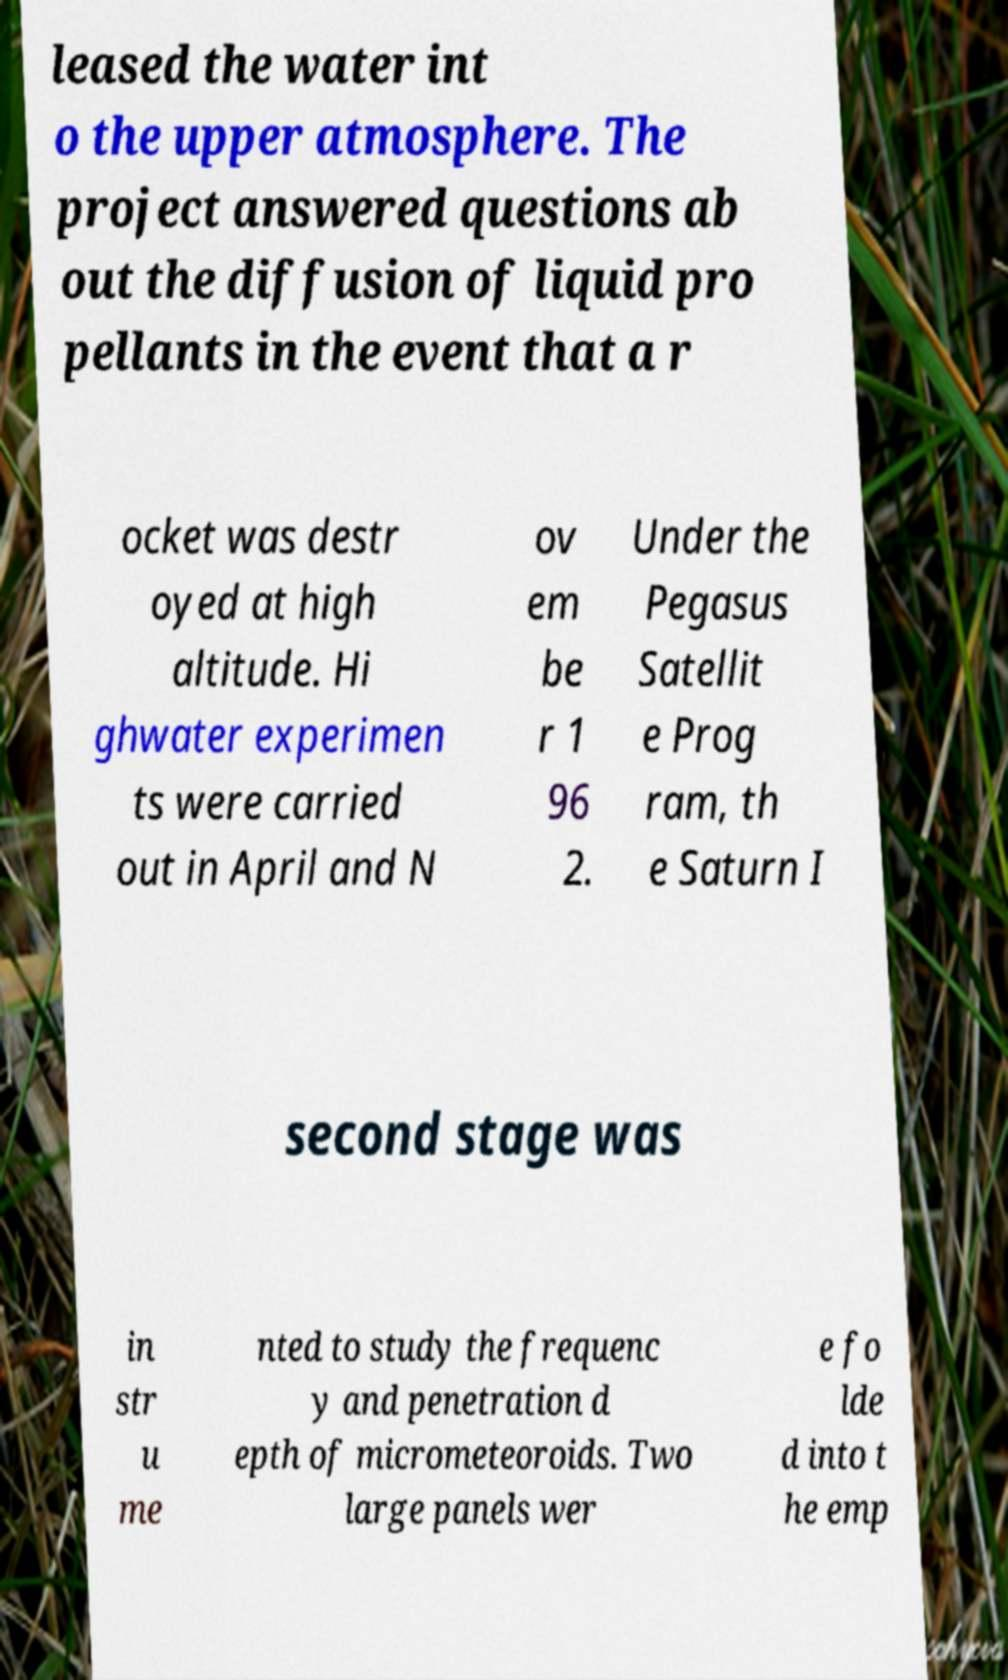There's text embedded in this image that I need extracted. Can you transcribe it verbatim? leased the water int o the upper atmosphere. The project answered questions ab out the diffusion of liquid pro pellants in the event that a r ocket was destr oyed at high altitude. Hi ghwater experimen ts were carried out in April and N ov em be r 1 96 2. Under the Pegasus Satellit e Prog ram, th e Saturn I second stage was in str u me nted to study the frequenc y and penetration d epth of micrometeoroids. Two large panels wer e fo lde d into t he emp 